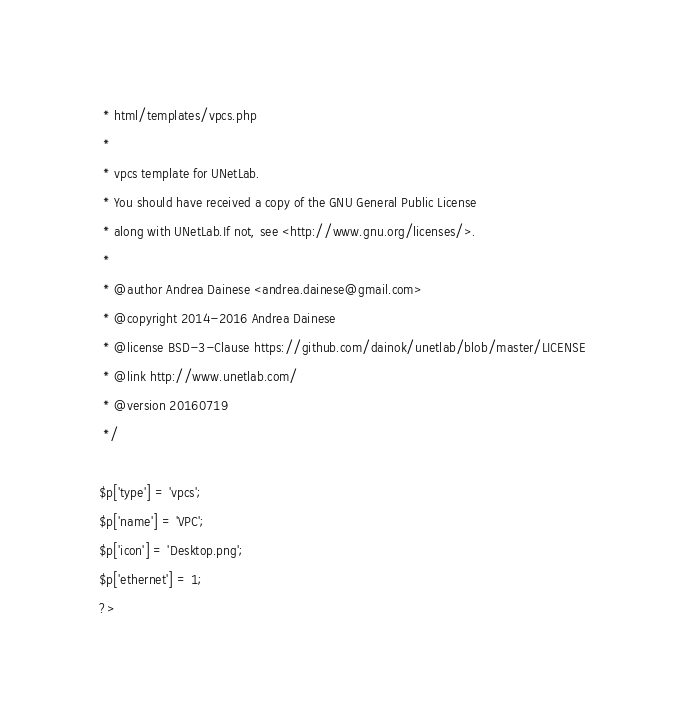<code> <loc_0><loc_0><loc_500><loc_500><_PHP_> * html/templates/vpcs.php
 *
 * vpcs template for UNetLab.
 * You should have received a copy of the GNU General Public License
 * along with UNetLab.If not, see <http://www.gnu.org/licenses/>.
 *
 * @author Andrea Dainese <andrea.dainese@gmail.com>
 * @copyright 2014-2016 Andrea Dainese
 * @license BSD-3-Clause https://github.com/dainok/unetlab/blob/master/LICENSE
 * @link http://www.unetlab.com/
 * @version 20160719
 */

$p['type'] = 'vpcs'; 
$p['name'] = 'VPC'; 
$p['icon'] = 'Desktop.png';
$p['ethernet'] = 1;
?>
</code> 